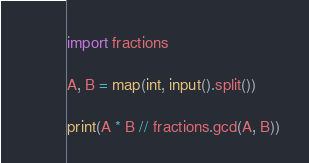Convert code to text. <code><loc_0><loc_0><loc_500><loc_500><_Python_>import fractions

A, B = map(int, input().split())

print(A * B // fractions.gcd(A, B))
</code> 